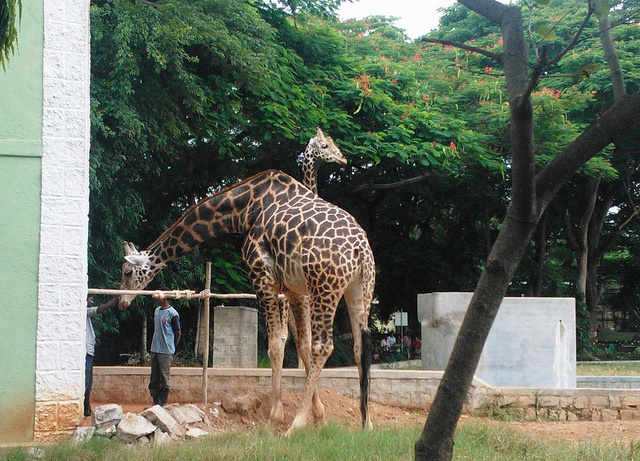Describe the objects in this image and their specific colors. I can see giraffe in black, gray, and tan tones, people in black and gray tones, giraffe in black, gray, darkgray, and ivory tones, people in black, gray, and darkgray tones, and people in black, maroon, and gray tones in this image. 